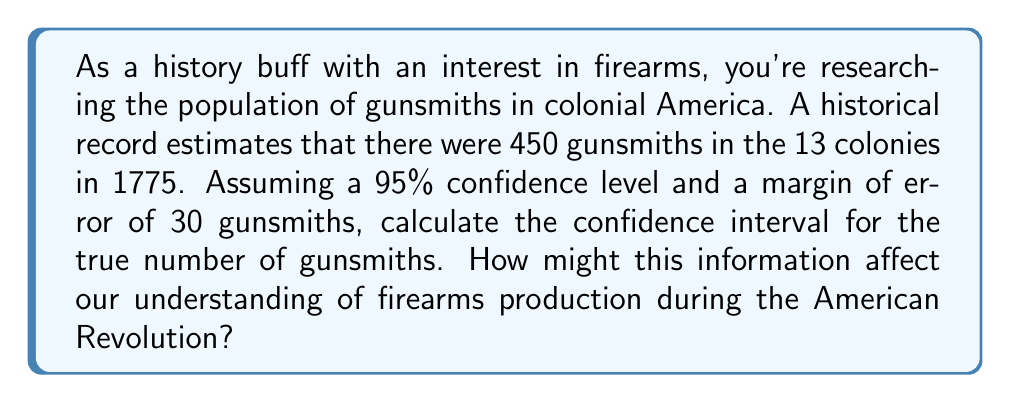Can you solve this math problem? Let's approach this step-by-step:

1) We're given:
   - Point estimate (x̄) = 450 gunsmiths
   - Confidence level = 95%
   - Margin of error (E) = 30 gunsmiths

2) The formula for a confidence interval is:

   $$ \text{CI} = \bar{x} \pm E $$

3) Substituting our values:

   $$ \text{CI} = 450 \pm 30 $$

4) Calculate the lower and upper bounds:
   
   Lower bound: $450 - 30 = 420$
   Upper bound: $450 + 30 = 480$

5) Therefore, we can say with 95% confidence that the true number of gunsmiths in 1775 was between 420 and 480.

This information affects our understanding of firearms production during the American Revolution in several ways:

a) It provides a range for the potential firearms manufacturing capacity of the colonies.
b) It suggests that even at the lower bound, there was a significant number of skilled gunsmiths available to support the revolutionary cause.
c) The upper bound indicates that firearms production could have been even more substantial than previously thought, potentially influencing our understanding of the colonists' readiness for conflict.
Answer: 95% CI: (420, 480) gunsmiths 